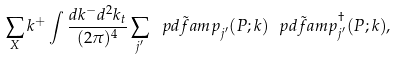Convert formula to latex. <formula><loc_0><loc_0><loc_500><loc_500>\sum _ { X } k ^ { + } \int \frac { d k ^ { - } d ^ { 2 } { k } _ { t } } { ( 2 \pi ) ^ { 4 } } \sum _ { j ^ { \prime } } \tilde { \ p d f a m p } _ { j ^ { \prime } } ( P ; k ) \tilde { \ p d f a m p } ^ { \dagger } _ { j ^ { \prime } } ( P ; k ) ,</formula> 